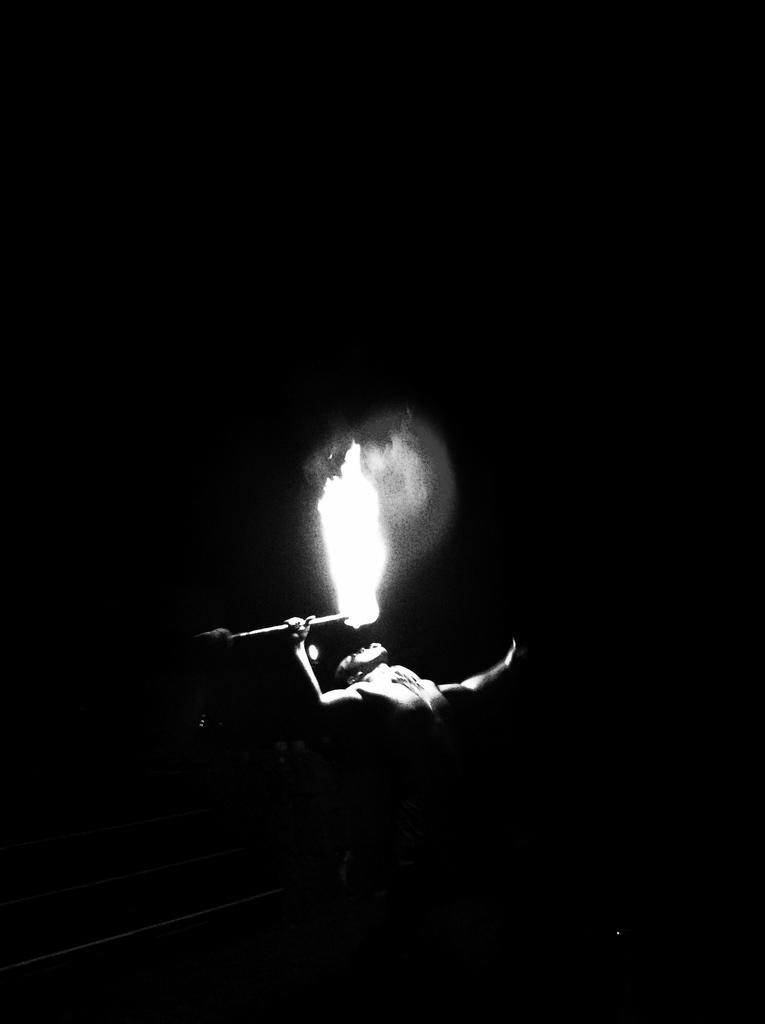What is the overall color scheme of the image? The background of the image is dark. Who or what is the main subject in the image? There is a man in the middle of the image. What is the man holding in the image? The man is holding a firestick. What is happening with the firestick in the image? There is fire on the firestick. Can you see the man's foot on the board in the image? There is no board or foot mentioned in the provided facts, so we cannot answer this question based on the image. 